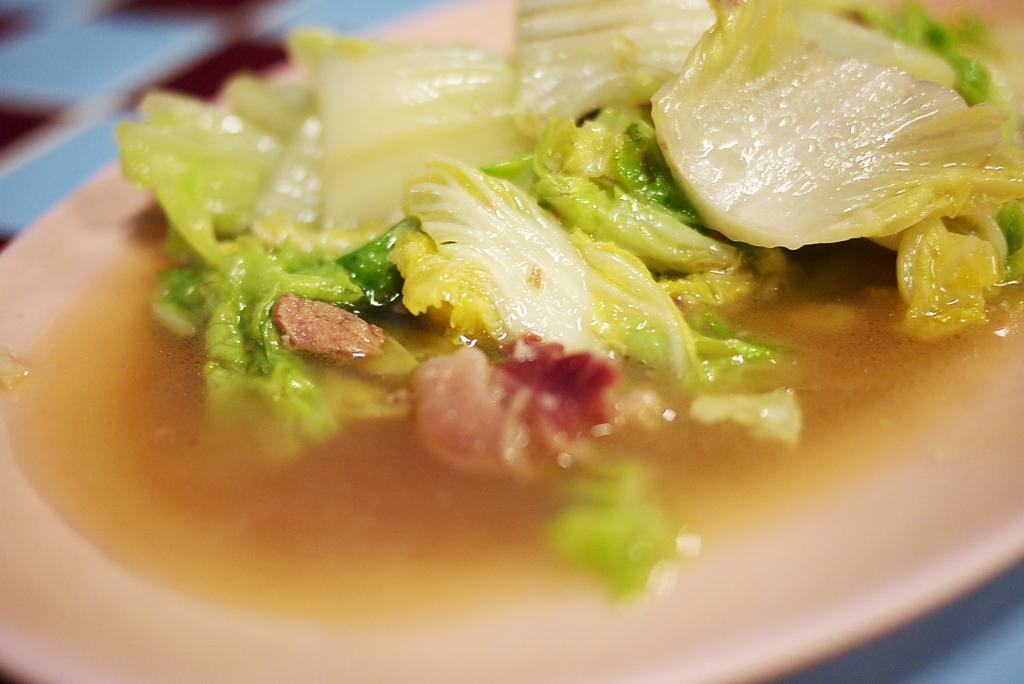How would you summarize this image in a sentence or two? In this image in front there is a food item on a plate. 